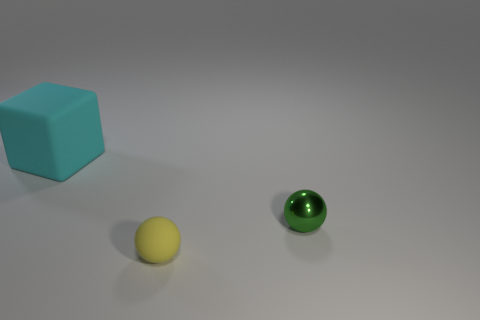Add 3 small green things. How many objects exist? 6 Subtract all spheres. How many objects are left? 1 Add 1 small brown cylinders. How many small brown cylinders exist? 1 Subtract 0 blue spheres. How many objects are left? 3 Subtract all gray metal spheres. Subtract all tiny yellow balls. How many objects are left? 2 Add 2 green objects. How many green objects are left? 3 